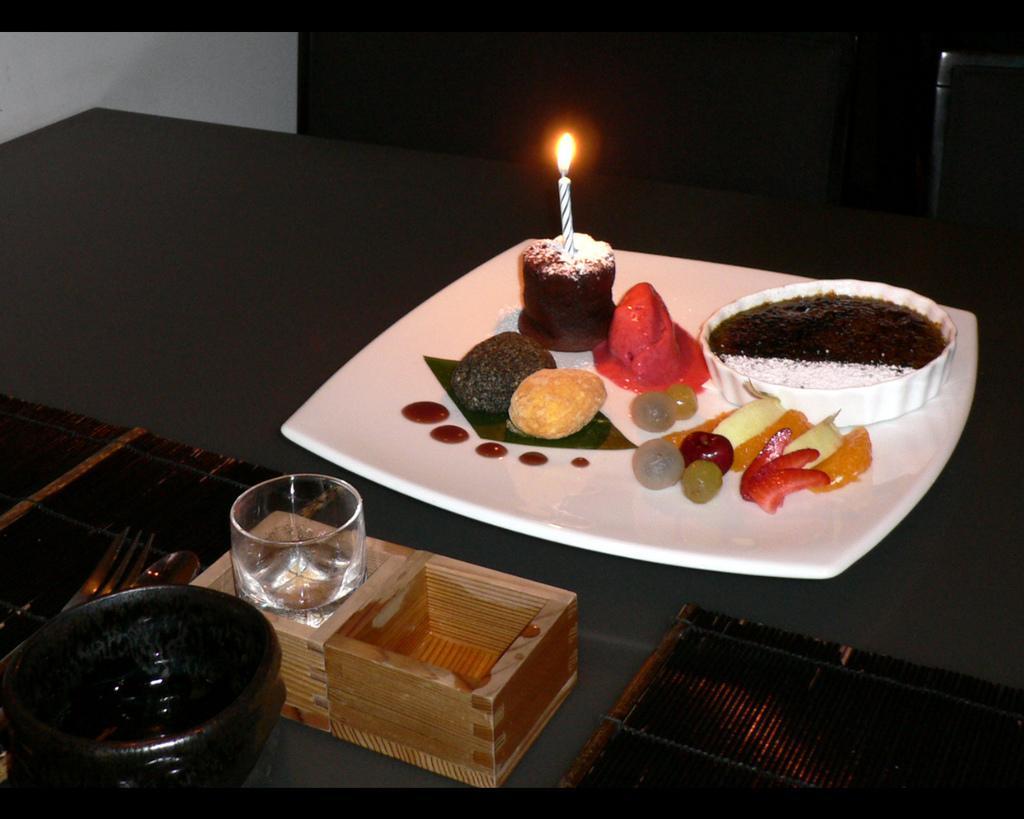Please provide a concise description of this image. In the image there is a table and on the table few desserts and fruits are served on a plate. Beside the plate there is a glass, spoons and a bowl. There are two chairs in front of the table and on the left side there is a wall. 